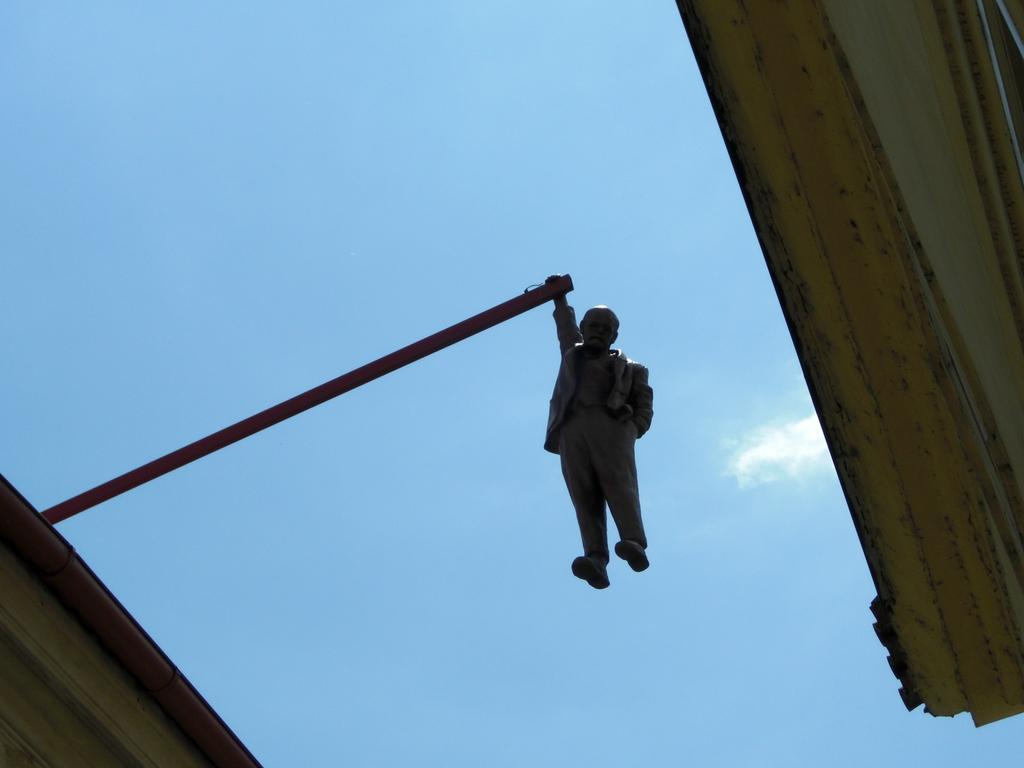What is the main subject in the center of the image? There is a statue in the center of the image. What structure can be seen on the right side of the image? There is a building on the right side of the image. What can be seen in the background of the image? The sky is visible in the background of the image. Where is the kitten playing with the wire in the image? There is no kitten or wire present in the image. What is the mass of the statue in the image? The mass of the statue cannot be determined from the image alone, as it would require additional information and measurements. 